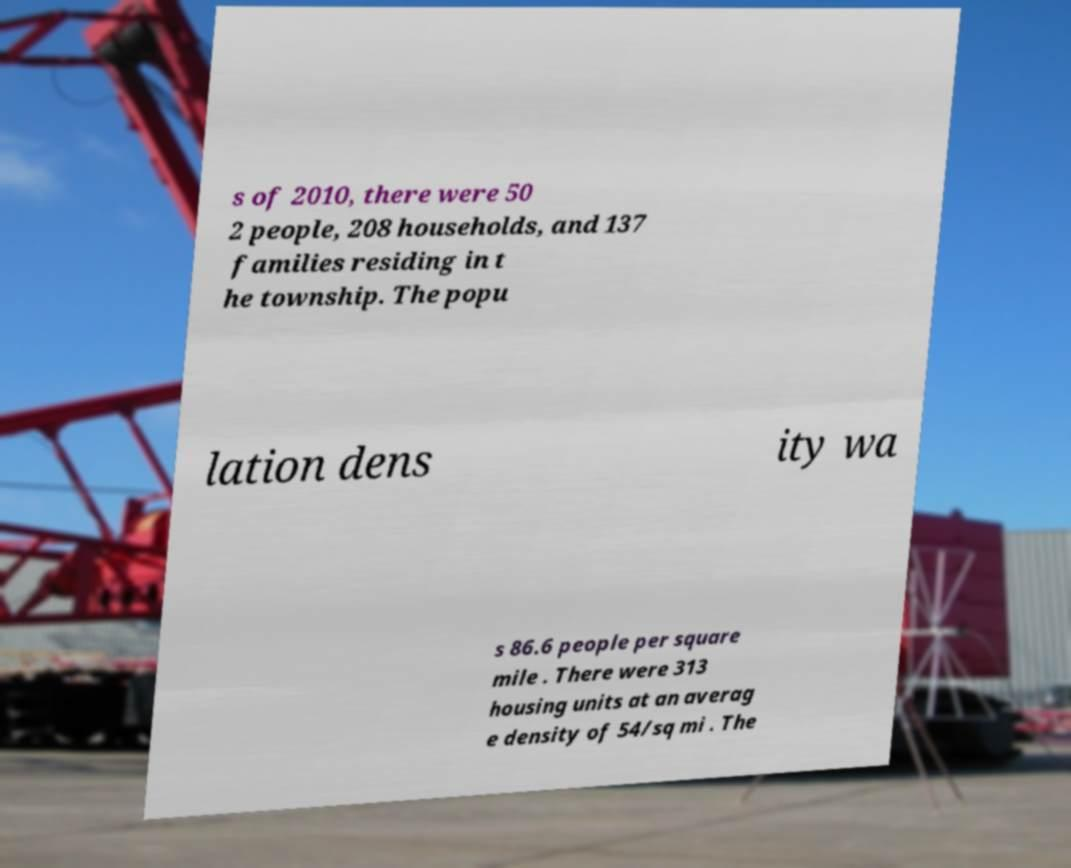There's text embedded in this image that I need extracted. Can you transcribe it verbatim? s of 2010, there were 50 2 people, 208 households, and 137 families residing in t he township. The popu lation dens ity wa s 86.6 people per square mile . There were 313 housing units at an averag e density of 54/sq mi . The 